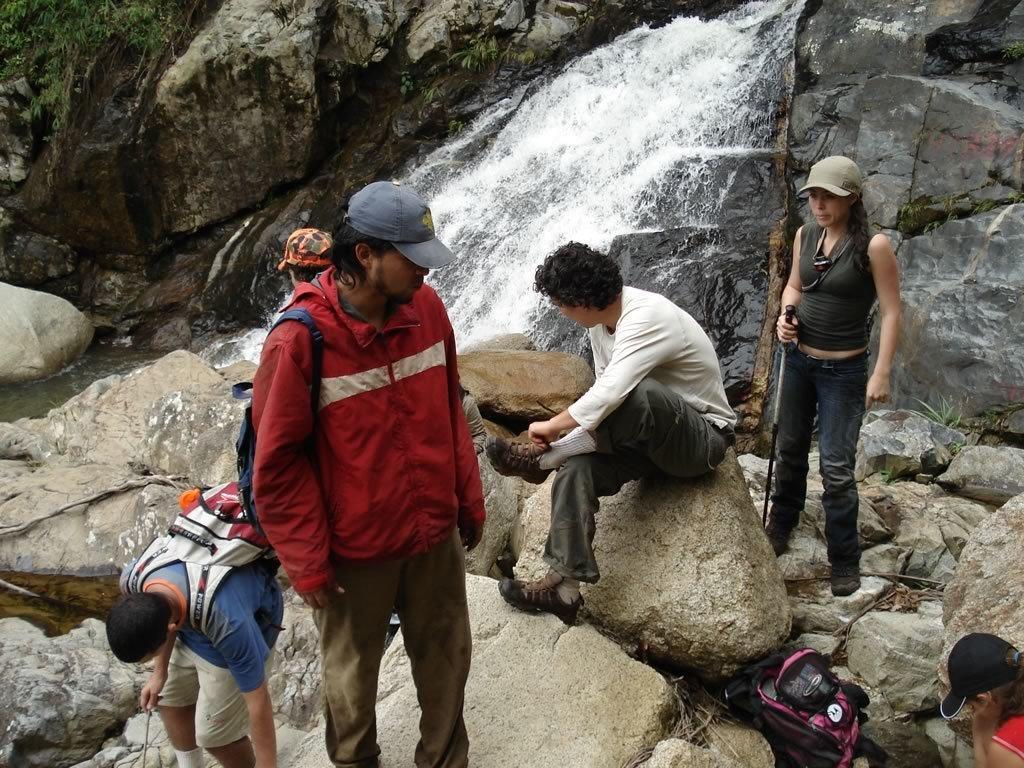Can you describe this image briefly? In this image there are a few people standing and sitting on the rocks, one of them is holding a stick in her hand, there is a bag, in front of them there is a waterfall and there is a plant. 